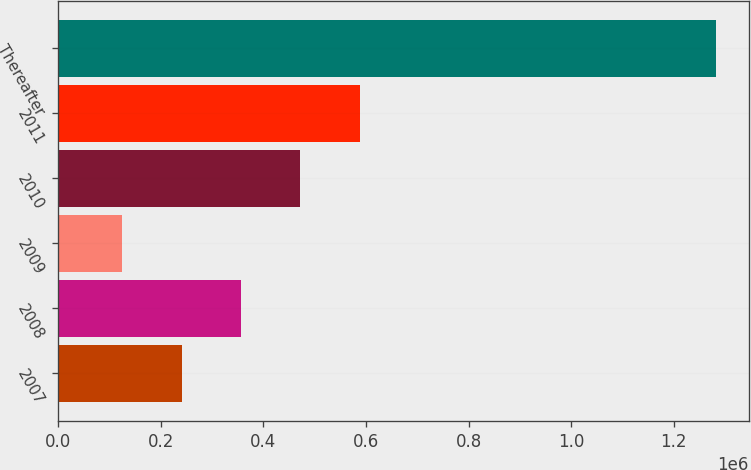Convert chart. <chart><loc_0><loc_0><loc_500><loc_500><bar_chart><fcel>2007<fcel>2008<fcel>2009<fcel>2010<fcel>2011<fcel>Thereafter<nl><fcel>240436<fcel>356143<fcel>124728<fcel>471850<fcel>587558<fcel>1.2818e+06<nl></chart> 